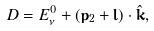Convert formula to latex. <formula><loc_0><loc_0><loc_500><loc_500>D = E _ { \nu } ^ { 0 } + ( { \mathbf p } _ { 2 } + { \mathbf l } ) \cdot { \hat { \mathbf k } } ,</formula> 